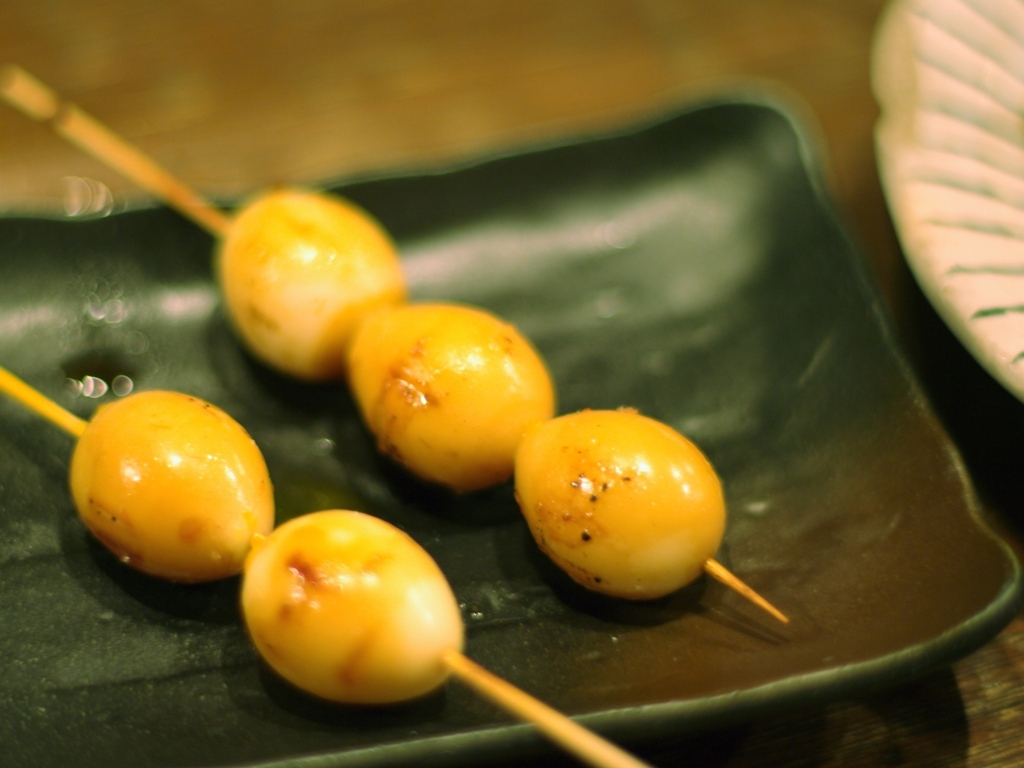How would you describe the lighting of the overall picture? A. overexposed B. well-lit C. dimly lit D. dark Answer with the option's letter from the given choices directly. The lighting in this image can be described as well-lit, which corresponds to option B. Each grilled item on the skewers is clearly visible with a soft shadow, indicating a gentle and balanced light source that avoids harshness or overexposure. The background shows no signs of light bleaching, and the visibility is good without any areas being too brightly illuminated or shrouded in shadows. 